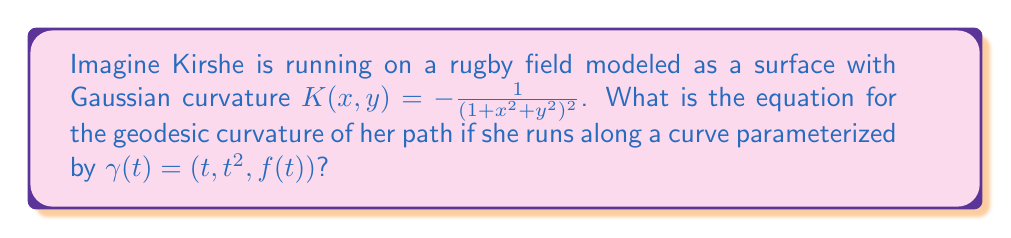Teach me how to tackle this problem. To solve this problem, we'll follow these steps:

1) Recall that the geodesic curvature $\kappa_g$ of a curve $\gamma(t)$ on a surface is given by:

   $$\kappa_g = \kappa \cos\theta$$

   where $\kappa$ is the curvature of $\gamma(t)$ and $\theta$ is the angle between the surface normal and the principal normal of $\gamma(t)$.

2) First, let's calculate the curvature $\kappa$. For a curve parameterized by $\gamma(t) = (x(t), y(t), z(t))$, the curvature is given by:

   $$\kappa = \frac{|\gamma'(t) \times \gamma''(t)|}{|\gamma'(t)|^3}$$

3) Calculate $\gamma'(t)$ and $\gamma''(t)$:
   
   $\gamma'(t) = (1, 2t, f'(t))$
   $\gamma''(t) = (0, 2, f''(t))$

4) Calculate $\gamma'(t) \times \gamma''(t)$:

   $$\gamma'(t) \times \gamma''(t) = (2f'(t) - 2tf''(t), -f''(t), 2)$$

5) Calculate $|\gamma'(t) \times \gamma''(t)|$:

   $$|\gamma'(t) \times \gamma''(t)| = \sqrt{(2f'(t) - 2tf''(t))^2 + (-f''(t))^2 + 4}$$

6) Calculate $|\gamma'(t)|$:

   $$|\gamma'(t)| = \sqrt{1 + 4t^2 + (f'(t))^2}$$

7) Therefore, the curvature $\kappa$ is:

   $$\kappa = \frac{\sqrt{(2f'(t) - 2tf''(t))^2 + (f''(t))^2 + 4}}{(1 + 4t^2 + (f'(t))^2)^{3/2}}$$

8) Now, we need to calculate $\cos\theta$. The surface normal $N$ is parallel to $\nabla(z-f(x,y))$:

   $$N = (-f_x, -f_y, 1)$$

   The principal normal of $\gamma(t)$ is:

   $$n = \frac{\gamma''(t) - (\gamma''(t) \cdot T)T}{|\gamma''(t) - (\gamma''(t) \cdot T)T|}$$

   where $T = \frac{\gamma'(t)}{|\gamma'(t)|}$ is the unit tangent vector.

9) The calculation of $\cos\theta$ involves the dot product of these normalized vectors, which is a complex expression in terms of $f$ and its derivatives.

10) The geodesic curvature $\kappa_g$ is the product of $\kappa$ and this $\cos\theta$ term.
Answer: $\kappa_g = \frac{\sqrt{(2f'(t) - 2tf''(t))^2 + (f''(t))^2 + 4}}{(1 + 4t^2 + (f'(t))^2)^{3/2}} \cdot \cos\theta$, where $\cos\theta$ is the dot product of the normalized surface normal and the principal normal of $\gamma(t)$. 